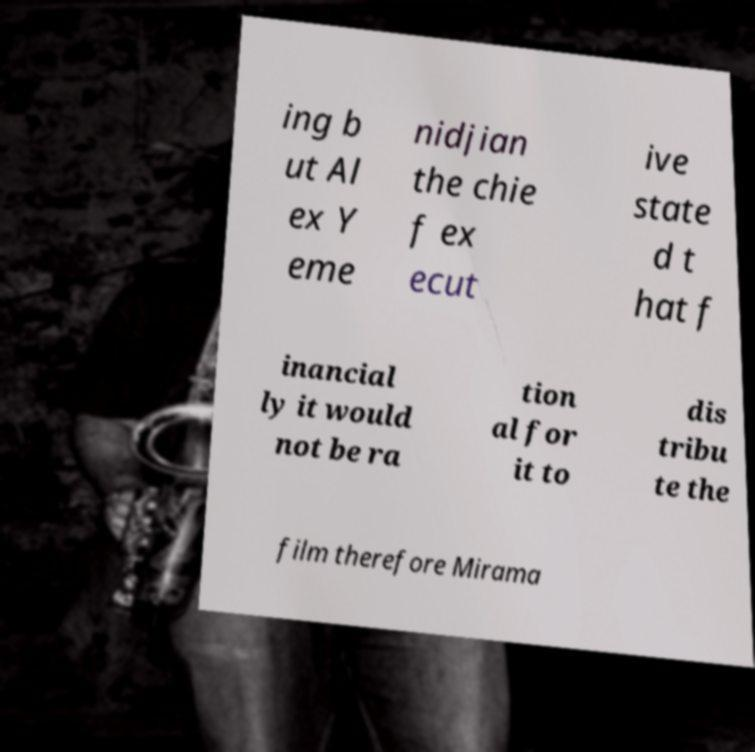Could you assist in decoding the text presented in this image and type it out clearly? ing b ut Al ex Y eme nidjian the chie f ex ecut ive state d t hat f inancial ly it would not be ra tion al for it to dis tribu te the film therefore Mirama 